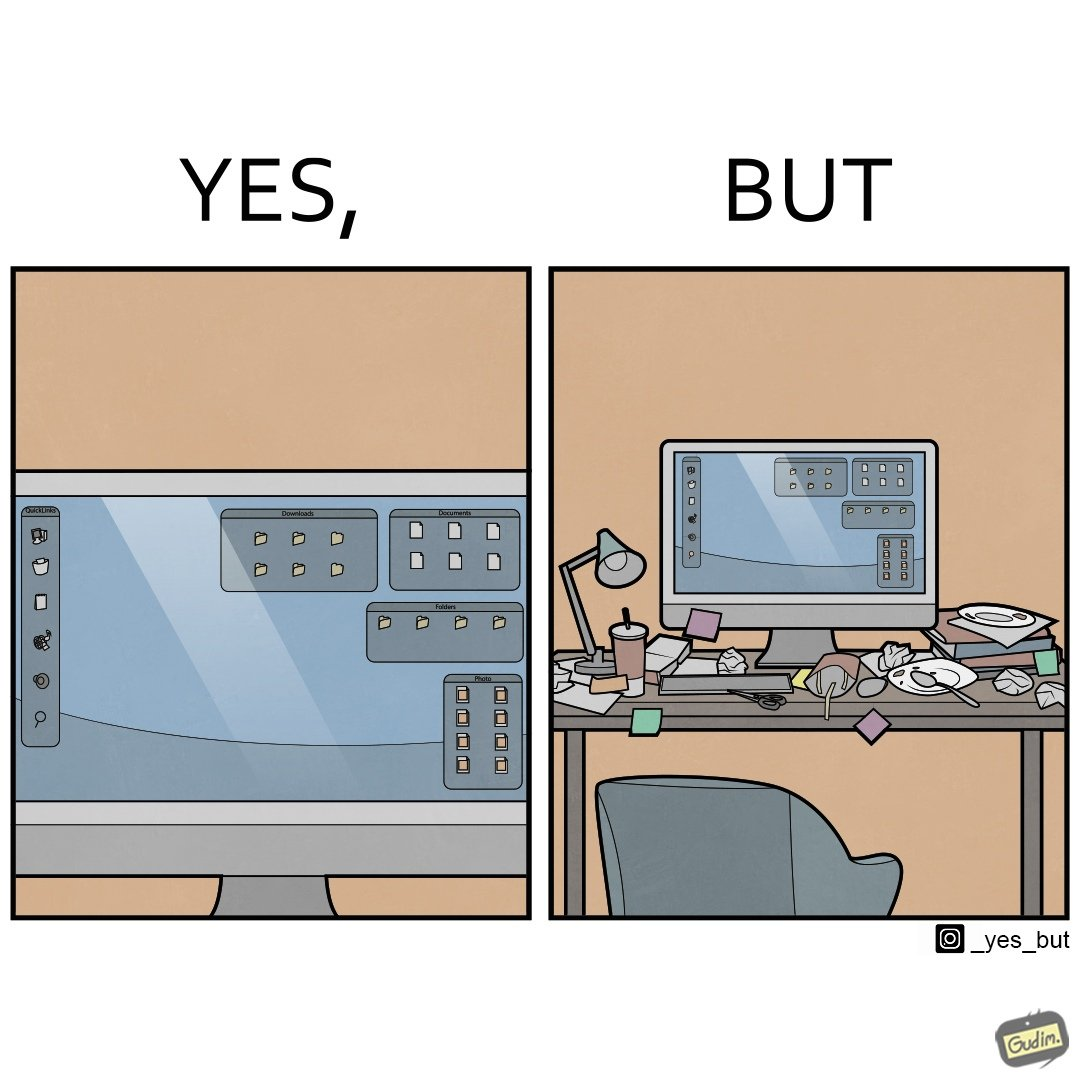Describe what you see in this image. The image is ironical, as the folder icons on the desktop screen are very neatly arranged, while the person using the computer has littered the table with used food packets, dirty plates, and wrappers. 